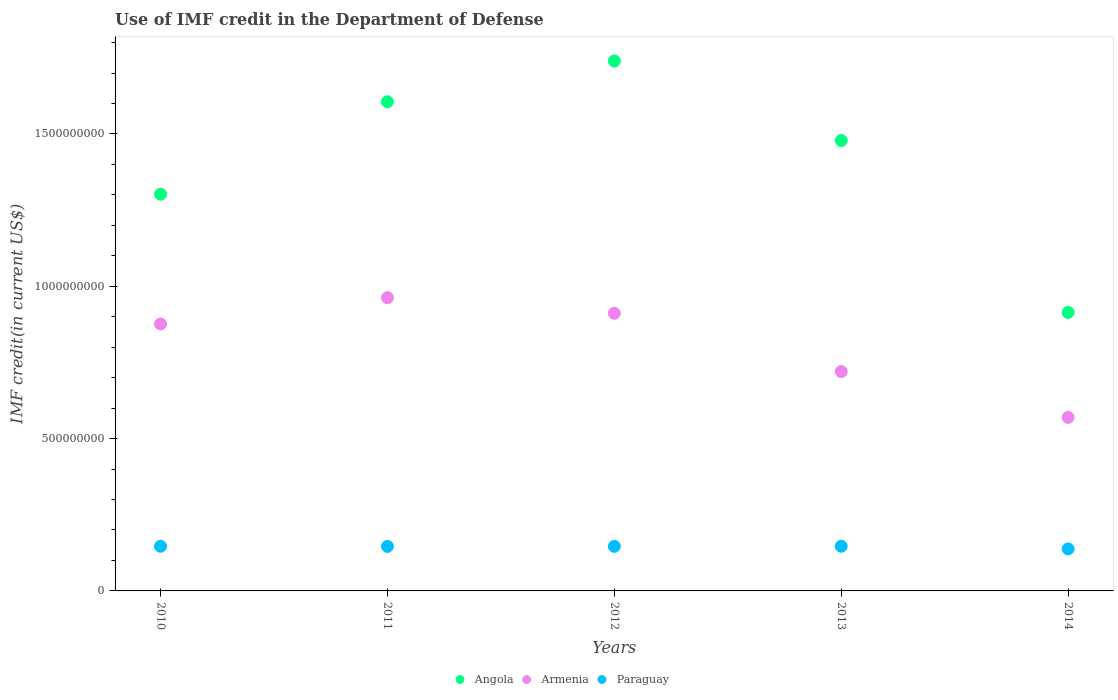How many different coloured dotlines are there?
Make the answer very short. 3. Is the number of dotlines equal to the number of legend labels?
Your answer should be very brief. Yes. What is the IMF credit in the Department of Defense in Angola in 2011?
Keep it short and to the point. 1.61e+09. Across all years, what is the maximum IMF credit in the Department of Defense in Angola?
Offer a very short reply. 1.74e+09. Across all years, what is the minimum IMF credit in the Department of Defense in Angola?
Make the answer very short. 9.14e+08. In which year was the IMF credit in the Department of Defense in Paraguay maximum?
Your answer should be compact. 2010. What is the total IMF credit in the Department of Defense in Armenia in the graph?
Your response must be concise. 4.04e+09. What is the difference between the IMF credit in the Department of Defense in Angola in 2013 and that in 2014?
Give a very brief answer. 5.65e+08. What is the difference between the IMF credit in the Department of Defense in Paraguay in 2013 and the IMF credit in the Department of Defense in Angola in 2010?
Your response must be concise. -1.16e+09. What is the average IMF credit in the Department of Defense in Angola per year?
Make the answer very short. 1.41e+09. In the year 2014, what is the difference between the IMF credit in the Department of Defense in Paraguay and IMF credit in the Department of Defense in Armenia?
Ensure brevity in your answer.  -4.32e+08. In how many years, is the IMF credit in the Department of Defense in Armenia greater than 1400000000 US$?
Offer a terse response. 0. What is the ratio of the IMF credit in the Department of Defense in Angola in 2011 to that in 2012?
Offer a terse response. 0.92. Is the difference between the IMF credit in the Department of Defense in Paraguay in 2010 and 2013 greater than the difference between the IMF credit in the Department of Defense in Armenia in 2010 and 2013?
Offer a very short reply. No. What is the difference between the highest and the second highest IMF credit in the Department of Defense in Angola?
Ensure brevity in your answer.  1.34e+08. What is the difference between the highest and the lowest IMF credit in the Department of Defense in Angola?
Give a very brief answer. 8.26e+08. In how many years, is the IMF credit in the Department of Defense in Paraguay greater than the average IMF credit in the Department of Defense in Paraguay taken over all years?
Your answer should be compact. 4. Is the sum of the IMF credit in the Department of Defense in Angola in 2013 and 2014 greater than the maximum IMF credit in the Department of Defense in Paraguay across all years?
Your answer should be compact. Yes. Is it the case that in every year, the sum of the IMF credit in the Department of Defense in Angola and IMF credit in the Department of Defense in Paraguay  is greater than the IMF credit in the Department of Defense in Armenia?
Ensure brevity in your answer.  Yes. Is the IMF credit in the Department of Defense in Armenia strictly greater than the IMF credit in the Department of Defense in Angola over the years?
Provide a succinct answer. No. How many dotlines are there?
Give a very brief answer. 3. How many years are there in the graph?
Ensure brevity in your answer.  5. Are the values on the major ticks of Y-axis written in scientific E-notation?
Give a very brief answer. No. Does the graph contain grids?
Provide a short and direct response. No. Where does the legend appear in the graph?
Provide a succinct answer. Bottom center. What is the title of the graph?
Make the answer very short. Use of IMF credit in the Department of Defense. What is the label or title of the Y-axis?
Ensure brevity in your answer.  IMF credit(in current US$). What is the IMF credit(in current US$) of Angola in 2010?
Ensure brevity in your answer.  1.30e+09. What is the IMF credit(in current US$) in Armenia in 2010?
Offer a very short reply. 8.76e+08. What is the IMF credit(in current US$) of Paraguay in 2010?
Offer a very short reply. 1.47e+08. What is the IMF credit(in current US$) in Angola in 2011?
Give a very brief answer. 1.61e+09. What is the IMF credit(in current US$) of Armenia in 2011?
Ensure brevity in your answer.  9.63e+08. What is the IMF credit(in current US$) in Paraguay in 2011?
Give a very brief answer. 1.46e+08. What is the IMF credit(in current US$) in Angola in 2012?
Your answer should be compact. 1.74e+09. What is the IMF credit(in current US$) in Armenia in 2012?
Make the answer very short. 9.11e+08. What is the IMF credit(in current US$) of Paraguay in 2012?
Make the answer very short. 1.46e+08. What is the IMF credit(in current US$) of Angola in 2013?
Ensure brevity in your answer.  1.48e+09. What is the IMF credit(in current US$) in Armenia in 2013?
Offer a terse response. 7.20e+08. What is the IMF credit(in current US$) in Paraguay in 2013?
Your answer should be very brief. 1.47e+08. What is the IMF credit(in current US$) in Angola in 2014?
Give a very brief answer. 9.14e+08. What is the IMF credit(in current US$) in Armenia in 2014?
Provide a succinct answer. 5.70e+08. What is the IMF credit(in current US$) in Paraguay in 2014?
Give a very brief answer. 1.38e+08. Across all years, what is the maximum IMF credit(in current US$) in Angola?
Make the answer very short. 1.74e+09. Across all years, what is the maximum IMF credit(in current US$) of Armenia?
Offer a very short reply. 9.63e+08. Across all years, what is the maximum IMF credit(in current US$) in Paraguay?
Your answer should be compact. 1.47e+08. Across all years, what is the minimum IMF credit(in current US$) in Angola?
Provide a succinct answer. 9.14e+08. Across all years, what is the minimum IMF credit(in current US$) of Armenia?
Ensure brevity in your answer.  5.70e+08. Across all years, what is the minimum IMF credit(in current US$) in Paraguay?
Offer a very short reply. 1.38e+08. What is the total IMF credit(in current US$) of Angola in the graph?
Provide a short and direct response. 7.04e+09. What is the total IMF credit(in current US$) in Armenia in the graph?
Offer a very short reply. 4.04e+09. What is the total IMF credit(in current US$) in Paraguay in the graph?
Provide a short and direct response. 7.24e+08. What is the difference between the IMF credit(in current US$) in Angola in 2010 and that in 2011?
Ensure brevity in your answer.  -3.04e+08. What is the difference between the IMF credit(in current US$) in Armenia in 2010 and that in 2011?
Provide a short and direct response. -8.63e+07. What is the difference between the IMF credit(in current US$) of Paraguay in 2010 and that in 2011?
Offer a terse response. 4.53e+05. What is the difference between the IMF credit(in current US$) of Angola in 2010 and that in 2012?
Your answer should be compact. -4.37e+08. What is the difference between the IMF credit(in current US$) in Armenia in 2010 and that in 2012?
Give a very brief answer. -3.51e+07. What is the difference between the IMF credit(in current US$) of Paraguay in 2010 and that in 2012?
Give a very brief answer. 2.96e+05. What is the difference between the IMF credit(in current US$) in Angola in 2010 and that in 2013?
Provide a short and direct response. -1.76e+08. What is the difference between the IMF credit(in current US$) in Armenia in 2010 and that in 2013?
Your response must be concise. 1.56e+08. What is the difference between the IMF credit(in current US$) of Paraguay in 2010 and that in 2013?
Offer a very short reply. 3000. What is the difference between the IMF credit(in current US$) in Angola in 2010 and that in 2014?
Your answer should be very brief. 3.88e+08. What is the difference between the IMF credit(in current US$) in Armenia in 2010 and that in 2014?
Make the answer very short. 3.07e+08. What is the difference between the IMF credit(in current US$) of Paraguay in 2010 and that in 2014?
Ensure brevity in your answer.  8.68e+06. What is the difference between the IMF credit(in current US$) in Angola in 2011 and that in 2012?
Offer a terse response. -1.34e+08. What is the difference between the IMF credit(in current US$) of Armenia in 2011 and that in 2012?
Provide a succinct answer. 5.12e+07. What is the difference between the IMF credit(in current US$) of Paraguay in 2011 and that in 2012?
Provide a succinct answer. -1.57e+05. What is the difference between the IMF credit(in current US$) of Angola in 2011 and that in 2013?
Your answer should be compact. 1.27e+08. What is the difference between the IMF credit(in current US$) in Armenia in 2011 and that in 2013?
Give a very brief answer. 2.42e+08. What is the difference between the IMF credit(in current US$) in Paraguay in 2011 and that in 2013?
Provide a short and direct response. -4.50e+05. What is the difference between the IMF credit(in current US$) of Angola in 2011 and that in 2014?
Your response must be concise. 6.92e+08. What is the difference between the IMF credit(in current US$) in Armenia in 2011 and that in 2014?
Provide a succinct answer. 3.93e+08. What is the difference between the IMF credit(in current US$) of Paraguay in 2011 and that in 2014?
Provide a succinct answer. 8.23e+06. What is the difference between the IMF credit(in current US$) in Angola in 2012 and that in 2013?
Ensure brevity in your answer.  2.61e+08. What is the difference between the IMF credit(in current US$) of Armenia in 2012 and that in 2013?
Your response must be concise. 1.91e+08. What is the difference between the IMF credit(in current US$) of Paraguay in 2012 and that in 2013?
Give a very brief answer. -2.93e+05. What is the difference between the IMF credit(in current US$) in Angola in 2012 and that in 2014?
Keep it short and to the point. 8.26e+08. What is the difference between the IMF credit(in current US$) of Armenia in 2012 and that in 2014?
Your answer should be very brief. 3.42e+08. What is the difference between the IMF credit(in current US$) in Paraguay in 2012 and that in 2014?
Give a very brief answer. 8.39e+06. What is the difference between the IMF credit(in current US$) of Angola in 2013 and that in 2014?
Provide a short and direct response. 5.65e+08. What is the difference between the IMF credit(in current US$) in Armenia in 2013 and that in 2014?
Your response must be concise. 1.51e+08. What is the difference between the IMF credit(in current US$) of Paraguay in 2013 and that in 2014?
Offer a very short reply. 8.68e+06. What is the difference between the IMF credit(in current US$) in Angola in 2010 and the IMF credit(in current US$) in Armenia in 2011?
Your answer should be compact. 3.40e+08. What is the difference between the IMF credit(in current US$) in Angola in 2010 and the IMF credit(in current US$) in Paraguay in 2011?
Your answer should be very brief. 1.16e+09. What is the difference between the IMF credit(in current US$) in Armenia in 2010 and the IMF credit(in current US$) in Paraguay in 2011?
Provide a succinct answer. 7.30e+08. What is the difference between the IMF credit(in current US$) in Angola in 2010 and the IMF credit(in current US$) in Armenia in 2012?
Keep it short and to the point. 3.91e+08. What is the difference between the IMF credit(in current US$) of Angola in 2010 and the IMF credit(in current US$) of Paraguay in 2012?
Ensure brevity in your answer.  1.16e+09. What is the difference between the IMF credit(in current US$) in Armenia in 2010 and the IMF credit(in current US$) in Paraguay in 2012?
Keep it short and to the point. 7.30e+08. What is the difference between the IMF credit(in current US$) in Angola in 2010 and the IMF credit(in current US$) in Armenia in 2013?
Offer a very short reply. 5.82e+08. What is the difference between the IMF credit(in current US$) of Angola in 2010 and the IMF credit(in current US$) of Paraguay in 2013?
Make the answer very short. 1.16e+09. What is the difference between the IMF credit(in current US$) of Armenia in 2010 and the IMF credit(in current US$) of Paraguay in 2013?
Give a very brief answer. 7.30e+08. What is the difference between the IMF credit(in current US$) in Angola in 2010 and the IMF credit(in current US$) in Armenia in 2014?
Offer a very short reply. 7.33e+08. What is the difference between the IMF credit(in current US$) of Angola in 2010 and the IMF credit(in current US$) of Paraguay in 2014?
Give a very brief answer. 1.16e+09. What is the difference between the IMF credit(in current US$) of Armenia in 2010 and the IMF credit(in current US$) of Paraguay in 2014?
Make the answer very short. 7.38e+08. What is the difference between the IMF credit(in current US$) in Angola in 2011 and the IMF credit(in current US$) in Armenia in 2012?
Provide a short and direct response. 6.95e+08. What is the difference between the IMF credit(in current US$) of Angola in 2011 and the IMF credit(in current US$) of Paraguay in 2012?
Your answer should be very brief. 1.46e+09. What is the difference between the IMF credit(in current US$) of Armenia in 2011 and the IMF credit(in current US$) of Paraguay in 2012?
Your answer should be compact. 8.16e+08. What is the difference between the IMF credit(in current US$) of Angola in 2011 and the IMF credit(in current US$) of Armenia in 2013?
Offer a very short reply. 8.86e+08. What is the difference between the IMF credit(in current US$) of Angola in 2011 and the IMF credit(in current US$) of Paraguay in 2013?
Provide a succinct answer. 1.46e+09. What is the difference between the IMF credit(in current US$) of Armenia in 2011 and the IMF credit(in current US$) of Paraguay in 2013?
Provide a succinct answer. 8.16e+08. What is the difference between the IMF credit(in current US$) of Angola in 2011 and the IMF credit(in current US$) of Armenia in 2014?
Your answer should be compact. 1.04e+09. What is the difference between the IMF credit(in current US$) in Angola in 2011 and the IMF credit(in current US$) in Paraguay in 2014?
Your answer should be very brief. 1.47e+09. What is the difference between the IMF credit(in current US$) in Armenia in 2011 and the IMF credit(in current US$) in Paraguay in 2014?
Your answer should be compact. 8.25e+08. What is the difference between the IMF credit(in current US$) in Angola in 2012 and the IMF credit(in current US$) in Armenia in 2013?
Your response must be concise. 1.02e+09. What is the difference between the IMF credit(in current US$) of Angola in 2012 and the IMF credit(in current US$) of Paraguay in 2013?
Offer a very short reply. 1.59e+09. What is the difference between the IMF credit(in current US$) in Armenia in 2012 and the IMF credit(in current US$) in Paraguay in 2013?
Give a very brief answer. 7.65e+08. What is the difference between the IMF credit(in current US$) in Angola in 2012 and the IMF credit(in current US$) in Armenia in 2014?
Give a very brief answer. 1.17e+09. What is the difference between the IMF credit(in current US$) in Angola in 2012 and the IMF credit(in current US$) in Paraguay in 2014?
Keep it short and to the point. 1.60e+09. What is the difference between the IMF credit(in current US$) in Armenia in 2012 and the IMF credit(in current US$) in Paraguay in 2014?
Your answer should be very brief. 7.73e+08. What is the difference between the IMF credit(in current US$) of Angola in 2013 and the IMF credit(in current US$) of Armenia in 2014?
Provide a succinct answer. 9.09e+08. What is the difference between the IMF credit(in current US$) of Angola in 2013 and the IMF credit(in current US$) of Paraguay in 2014?
Your answer should be very brief. 1.34e+09. What is the difference between the IMF credit(in current US$) in Armenia in 2013 and the IMF credit(in current US$) in Paraguay in 2014?
Offer a terse response. 5.82e+08. What is the average IMF credit(in current US$) of Angola per year?
Offer a very short reply. 1.41e+09. What is the average IMF credit(in current US$) in Armenia per year?
Ensure brevity in your answer.  8.08e+08. What is the average IMF credit(in current US$) of Paraguay per year?
Provide a short and direct response. 1.45e+08. In the year 2010, what is the difference between the IMF credit(in current US$) in Angola and IMF credit(in current US$) in Armenia?
Ensure brevity in your answer.  4.26e+08. In the year 2010, what is the difference between the IMF credit(in current US$) in Angola and IMF credit(in current US$) in Paraguay?
Provide a succinct answer. 1.16e+09. In the year 2010, what is the difference between the IMF credit(in current US$) of Armenia and IMF credit(in current US$) of Paraguay?
Provide a succinct answer. 7.30e+08. In the year 2011, what is the difference between the IMF credit(in current US$) of Angola and IMF credit(in current US$) of Armenia?
Offer a terse response. 6.43e+08. In the year 2011, what is the difference between the IMF credit(in current US$) in Angola and IMF credit(in current US$) in Paraguay?
Keep it short and to the point. 1.46e+09. In the year 2011, what is the difference between the IMF credit(in current US$) in Armenia and IMF credit(in current US$) in Paraguay?
Your response must be concise. 8.16e+08. In the year 2012, what is the difference between the IMF credit(in current US$) in Angola and IMF credit(in current US$) in Armenia?
Ensure brevity in your answer.  8.28e+08. In the year 2012, what is the difference between the IMF credit(in current US$) in Angola and IMF credit(in current US$) in Paraguay?
Offer a very short reply. 1.59e+09. In the year 2012, what is the difference between the IMF credit(in current US$) of Armenia and IMF credit(in current US$) of Paraguay?
Ensure brevity in your answer.  7.65e+08. In the year 2013, what is the difference between the IMF credit(in current US$) of Angola and IMF credit(in current US$) of Armenia?
Your answer should be very brief. 7.58e+08. In the year 2013, what is the difference between the IMF credit(in current US$) in Angola and IMF credit(in current US$) in Paraguay?
Keep it short and to the point. 1.33e+09. In the year 2013, what is the difference between the IMF credit(in current US$) of Armenia and IMF credit(in current US$) of Paraguay?
Make the answer very short. 5.74e+08. In the year 2014, what is the difference between the IMF credit(in current US$) in Angola and IMF credit(in current US$) in Armenia?
Make the answer very short. 3.44e+08. In the year 2014, what is the difference between the IMF credit(in current US$) in Angola and IMF credit(in current US$) in Paraguay?
Give a very brief answer. 7.76e+08. In the year 2014, what is the difference between the IMF credit(in current US$) in Armenia and IMF credit(in current US$) in Paraguay?
Give a very brief answer. 4.32e+08. What is the ratio of the IMF credit(in current US$) in Angola in 2010 to that in 2011?
Offer a very short reply. 0.81. What is the ratio of the IMF credit(in current US$) in Armenia in 2010 to that in 2011?
Offer a terse response. 0.91. What is the ratio of the IMF credit(in current US$) of Angola in 2010 to that in 2012?
Your answer should be very brief. 0.75. What is the ratio of the IMF credit(in current US$) of Armenia in 2010 to that in 2012?
Offer a very short reply. 0.96. What is the ratio of the IMF credit(in current US$) in Paraguay in 2010 to that in 2012?
Your response must be concise. 1. What is the ratio of the IMF credit(in current US$) of Angola in 2010 to that in 2013?
Your answer should be very brief. 0.88. What is the ratio of the IMF credit(in current US$) in Armenia in 2010 to that in 2013?
Your answer should be very brief. 1.22. What is the ratio of the IMF credit(in current US$) of Angola in 2010 to that in 2014?
Your answer should be compact. 1.42. What is the ratio of the IMF credit(in current US$) of Armenia in 2010 to that in 2014?
Provide a short and direct response. 1.54. What is the ratio of the IMF credit(in current US$) in Paraguay in 2010 to that in 2014?
Provide a succinct answer. 1.06. What is the ratio of the IMF credit(in current US$) of Armenia in 2011 to that in 2012?
Offer a very short reply. 1.06. What is the ratio of the IMF credit(in current US$) in Angola in 2011 to that in 2013?
Offer a terse response. 1.09. What is the ratio of the IMF credit(in current US$) in Armenia in 2011 to that in 2013?
Provide a succinct answer. 1.34. What is the ratio of the IMF credit(in current US$) in Paraguay in 2011 to that in 2013?
Offer a very short reply. 1. What is the ratio of the IMF credit(in current US$) of Angola in 2011 to that in 2014?
Offer a terse response. 1.76. What is the ratio of the IMF credit(in current US$) in Armenia in 2011 to that in 2014?
Your response must be concise. 1.69. What is the ratio of the IMF credit(in current US$) in Paraguay in 2011 to that in 2014?
Keep it short and to the point. 1.06. What is the ratio of the IMF credit(in current US$) of Angola in 2012 to that in 2013?
Ensure brevity in your answer.  1.18. What is the ratio of the IMF credit(in current US$) in Armenia in 2012 to that in 2013?
Your response must be concise. 1.27. What is the ratio of the IMF credit(in current US$) of Angola in 2012 to that in 2014?
Provide a short and direct response. 1.9. What is the ratio of the IMF credit(in current US$) in Armenia in 2012 to that in 2014?
Ensure brevity in your answer.  1.6. What is the ratio of the IMF credit(in current US$) of Paraguay in 2012 to that in 2014?
Provide a short and direct response. 1.06. What is the ratio of the IMF credit(in current US$) in Angola in 2013 to that in 2014?
Give a very brief answer. 1.62. What is the ratio of the IMF credit(in current US$) of Armenia in 2013 to that in 2014?
Provide a short and direct response. 1.26. What is the ratio of the IMF credit(in current US$) of Paraguay in 2013 to that in 2014?
Keep it short and to the point. 1.06. What is the difference between the highest and the second highest IMF credit(in current US$) in Angola?
Provide a succinct answer. 1.34e+08. What is the difference between the highest and the second highest IMF credit(in current US$) of Armenia?
Offer a very short reply. 5.12e+07. What is the difference between the highest and the second highest IMF credit(in current US$) in Paraguay?
Your answer should be very brief. 3000. What is the difference between the highest and the lowest IMF credit(in current US$) in Angola?
Offer a very short reply. 8.26e+08. What is the difference between the highest and the lowest IMF credit(in current US$) in Armenia?
Make the answer very short. 3.93e+08. What is the difference between the highest and the lowest IMF credit(in current US$) in Paraguay?
Make the answer very short. 8.68e+06. 